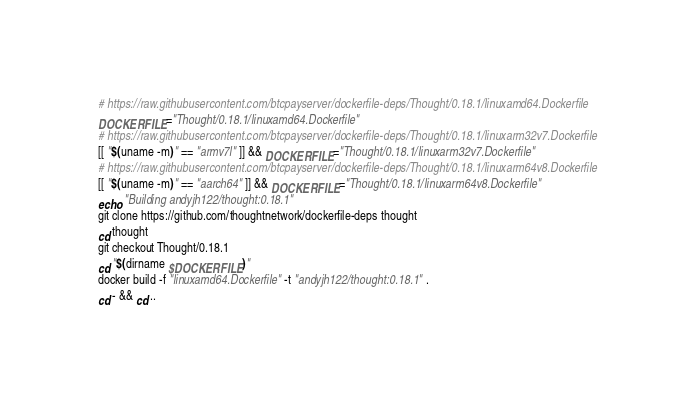<code> <loc_0><loc_0><loc_500><loc_500><_Bash_># https://raw.githubusercontent.com/btcpayserver/dockerfile-deps/Thought/0.18.1/linuxamd64.Dockerfile
DOCKERFILE="Thought/0.18.1/linuxamd64.Dockerfile"
# https://raw.githubusercontent.com/btcpayserver/dockerfile-deps/Thought/0.18.1/linuxarm32v7.Dockerfile
[[ "$(uname -m)" == "armv7l" ]] && DOCKERFILE="Thought/0.18.1/linuxarm32v7.Dockerfile"
# https://raw.githubusercontent.com/btcpayserver/dockerfile-deps/Thought/0.18.1/linuxarm64v8.Dockerfile
[[ "$(uname -m)" == "aarch64" ]] && DOCKERFILE="Thought/0.18.1/linuxarm64v8.Dockerfile"
echo "Building andyjh122/thought:0.18.1"
git clone https://github.com/thoughtnetwork/dockerfile-deps thought
cd thought
git checkout Thought/0.18.1
cd "$(dirname $DOCKERFILE)"
docker build -f "linuxamd64.Dockerfile" -t "andyjh122/thought:0.18.1" .
cd - && cd ..

</code> 